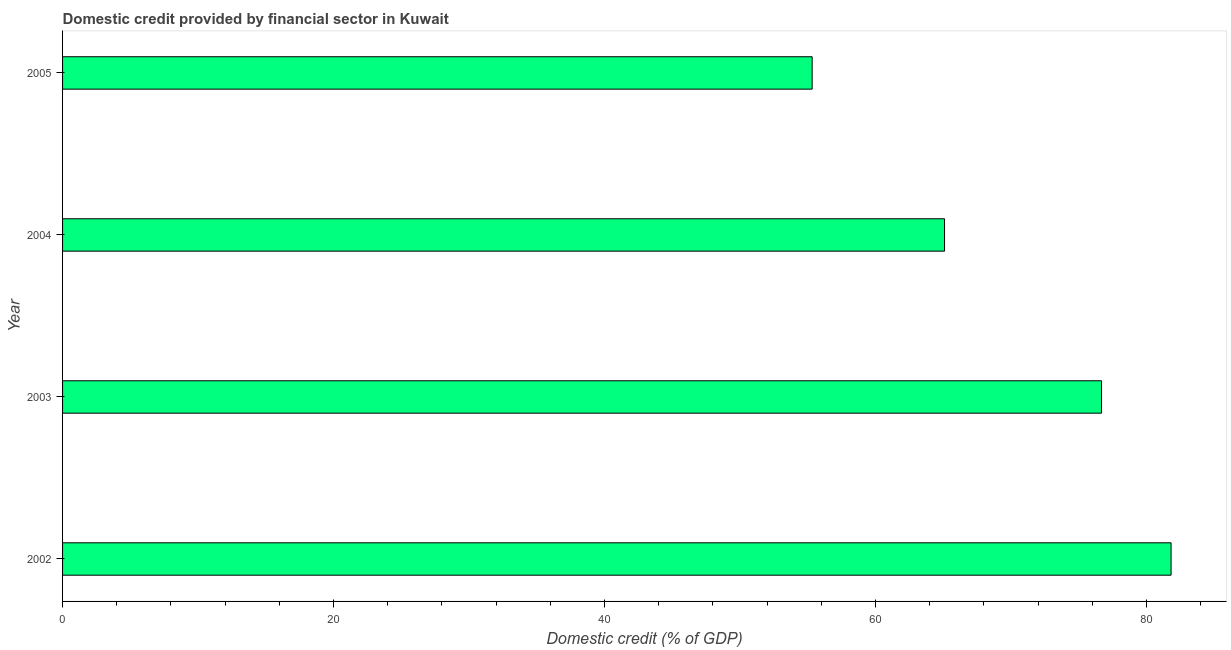What is the title of the graph?
Ensure brevity in your answer.  Domestic credit provided by financial sector in Kuwait. What is the label or title of the X-axis?
Give a very brief answer. Domestic credit (% of GDP). What is the domestic credit provided by financial sector in 2003?
Make the answer very short. 76.68. Across all years, what is the maximum domestic credit provided by financial sector?
Keep it short and to the point. 81.81. Across all years, what is the minimum domestic credit provided by financial sector?
Give a very brief answer. 55.32. In which year was the domestic credit provided by financial sector maximum?
Ensure brevity in your answer.  2002. In which year was the domestic credit provided by financial sector minimum?
Your answer should be very brief. 2005. What is the sum of the domestic credit provided by financial sector?
Make the answer very short. 278.9. What is the difference between the domestic credit provided by financial sector in 2002 and 2004?
Provide a short and direct response. 16.72. What is the average domestic credit provided by financial sector per year?
Your answer should be very brief. 69.72. What is the median domestic credit provided by financial sector?
Provide a succinct answer. 70.88. In how many years, is the domestic credit provided by financial sector greater than 16 %?
Make the answer very short. 4. Do a majority of the years between 2004 and 2005 (inclusive) have domestic credit provided by financial sector greater than 28 %?
Your response must be concise. Yes. What is the ratio of the domestic credit provided by financial sector in 2002 to that in 2005?
Offer a very short reply. 1.48. Is the domestic credit provided by financial sector in 2004 less than that in 2005?
Offer a very short reply. No. What is the difference between the highest and the second highest domestic credit provided by financial sector?
Make the answer very short. 5.13. Is the sum of the domestic credit provided by financial sector in 2002 and 2003 greater than the maximum domestic credit provided by financial sector across all years?
Offer a terse response. Yes. What is the difference between the highest and the lowest domestic credit provided by financial sector?
Make the answer very short. 26.49. In how many years, is the domestic credit provided by financial sector greater than the average domestic credit provided by financial sector taken over all years?
Your answer should be compact. 2. What is the difference between two consecutive major ticks on the X-axis?
Make the answer very short. 20. What is the Domestic credit (% of GDP) in 2002?
Offer a terse response. 81.81. What is the Domestic credit (% of GDP) in 2003?
Your response must be concise. 76.68. What is the Domestic credit (% of GDP) of 2004?
Make the answer very short. 65.09. What is the Domestic credit (% of GDP) in 2005?
Keep it short and to the point. 55.32. What is the difference between the Domestic credit (% of GDP) in 2002 and 2003?
Offer a terse response. 5.13. What is the difference between the Domestic credit (% of GDP) in 2002 and 2004?
Offer a very short reply. 16.72. What is the difference between the Domestic credit (% of GDP) in 2002 and 2005?
Your answer should be very brief. 26.49. What is the difference between the Domestic credit (% of GDP) in 2003 and 2004?
Give a very brief answer. 11.59. What is the difference between the Domestic credit (% of GDP) in 2003 and 2005?
Your answer should be very brief. 21.36. What is the difference between the Domestic credit (% of GDP) in 2004 and 2005?
Provide a succinct answer. 9.77. What is the ratio of the Domestic credit (% of GDP) in 2002 to that in 2003?
Offer a very short reply. 1.07. What is the ratio of the Domestic credit (% of GDP) in 2002 to that in 2004?
Provide a succinct answer. 1.26. What is the ratio of the Domestic credit (% of GDP) in 2002 to that in 2005?
Make the answer very short. 1.48. What is the ratio of the Domestic credit (% of GDP) in 2003 to that in 2004?
Provide a succinct answer. 1.18. What is the ratio of the Domestic credit (% of GDP) in 2003 to that in 2005?
Give a very brief answer. 1.39. What is the ratio of the Domestic credit (% of GDP) in 2004 to that in 2005?
Keep it short and to the point. 1.18. 